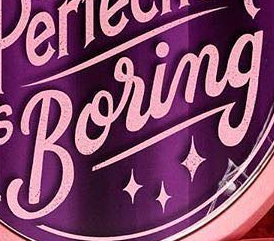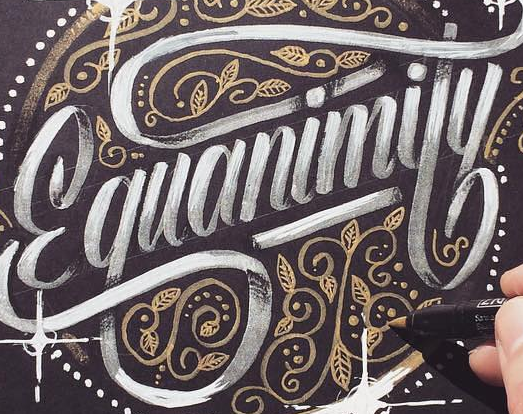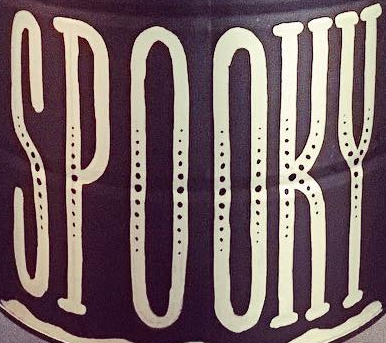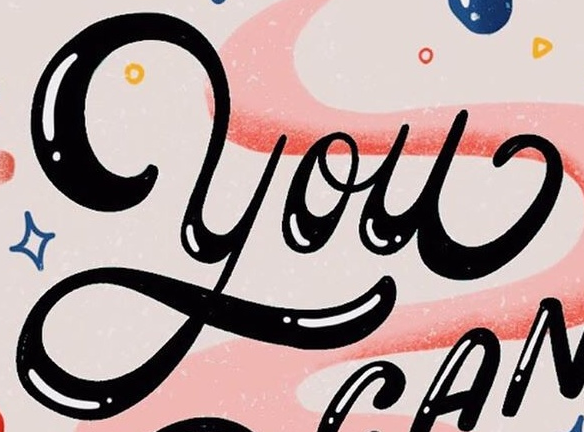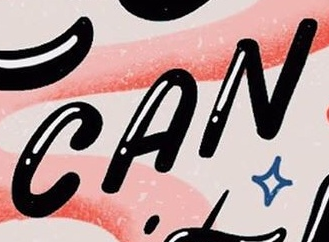Read the text content from these images in order, separated by a semicolon. Boring; Ɛquanimity; SPOOKY; You; CAN 